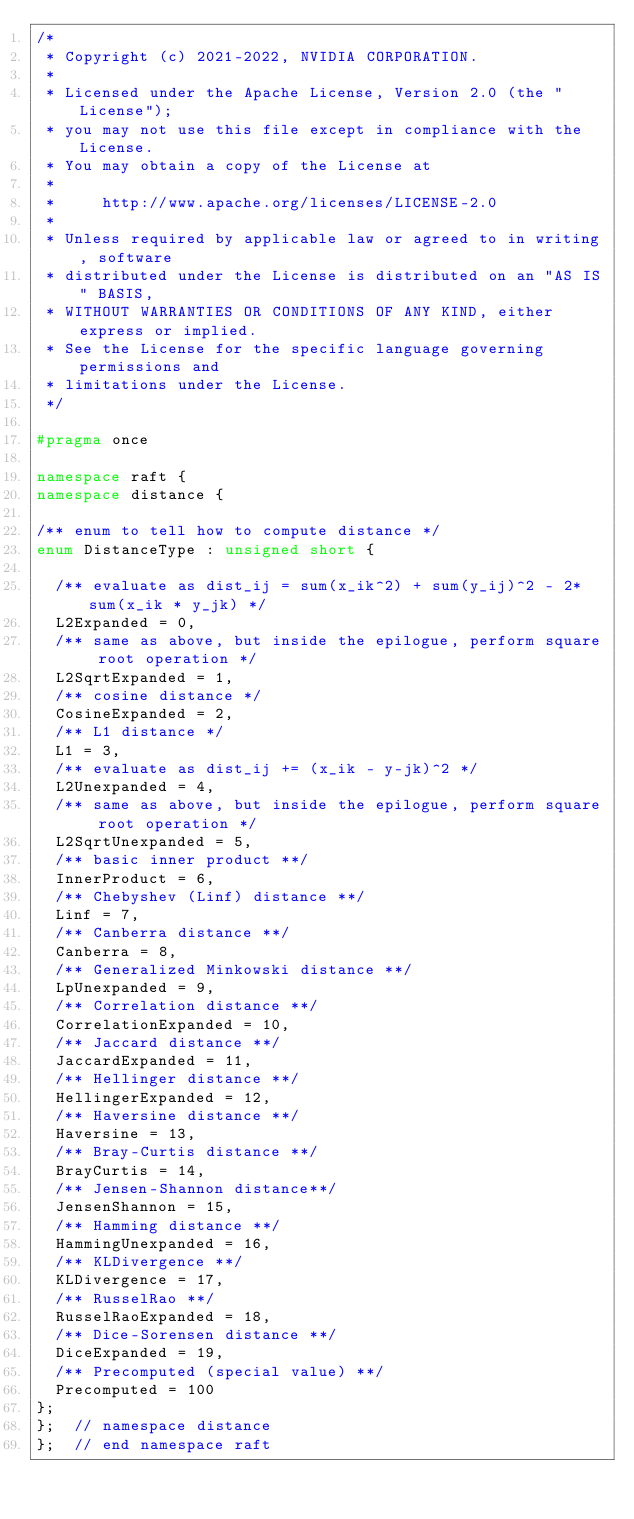<code> <loc_0><loc_0><loc_500><loc_500><_C++_>/*
 * Copyright (c) 2021-2022, NVIDIA CORPORATION.
 *
 * Licensed under the Apache License, Version 2.0 (the "License");
 * you may not use this file except in compliance with the License.
 * You may obtain a copy of the License at
 *
 *     http://www.apache.org/licenses/LICENSE-2.0
 *
 * Unless required by applicable law or agreed to in writing, software
 * distributed under the License is distributed on an "AS IS" BASIS,
 * WITHOUT WARRANTIES OR CONDITIONS OF ANY KIND, either express or implied.
 * See the License for the specific language governing permissions and
 * limitations under the License.
 */

#pragma once

namespace raft {
namespace distance {

/** enum to tell how to compute distance */
enum DistanceType : unsigned short {

  /** evaluate as dist_ij = sum(x_ik^2) + sum(y_ij)^2 - 2*sum(x_ik * y_jk) */
  L2Expanded = 0,
  /** same as above, but inside the epilogue, perform square root operation */
  L2SqrtExpanded = 1,
  /** cosine distance */
  CosineExpanded = 2,
  /** L1 distance */
  L1 = 3,
  /** evaluate as dist_ij += (x_ik - y-jk)^2 */
  L2Unexpanded = 4,
  /** same as above, but inside the epilogue, perform square root operation */
  L2SqrtUnexpanded = 5,
  /** basic inner product **/
  InnerProduct = 6,
  /** Chebyshev (Linf) distance **/
  Linf = 7,
  /** Canberra distance **/
  Canberra = 8,
  /** Generalized Minkowski distance **/
  LpUnexpanded = 9,
  /** Correlation distance **/
  CorrelationExpanded = 10,
  /** Jaccard distance **/
  JaccardExpanded = 11,
  /** Hellinger distance **/
  HellingerExpanded = 12,
  /** Haversine distance **/
  Haversine = 13,
  /** Bray-Curtis distance **/
  BrayCurtis = 14,
  /** Jensen-Shannon distance**/
  JensenShannon = 15,
  /** Hamming distance **/
  HammingUnexpanded = 16,
  /** KLDivergence **/
  KLDivergence = 17,
  /** RusselRao **/
  RusselRaoExpanded = 18,
  /** Dice-Sorensen distance **/
  DiceExpanded = 19,
  /** Precomputed (special value) **/
  Precomputed = 100
};
};  // namespace distance
};  // end namespace raft
</code> 